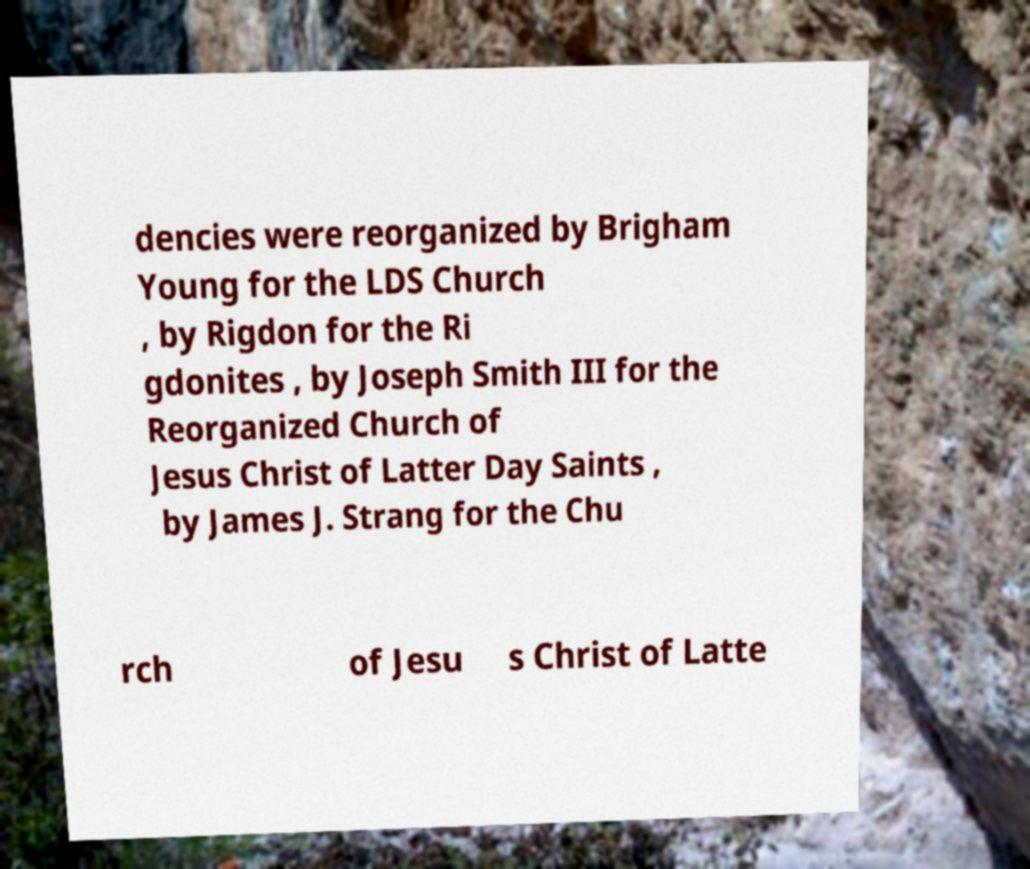Can you read and provide the text displayed in the image?This photo seems to have some interesting text. Can you extract and type it out for me? dencies were reorganized by Brigham Young for the LDS Church , by Rigdon for the Ri gdonites , by Joseph Smith III for the Reorganized Church of Jesus Christ of Latter Day Saints , by James J. Strang for the Chu rch of Jesu s Christ of Latte 